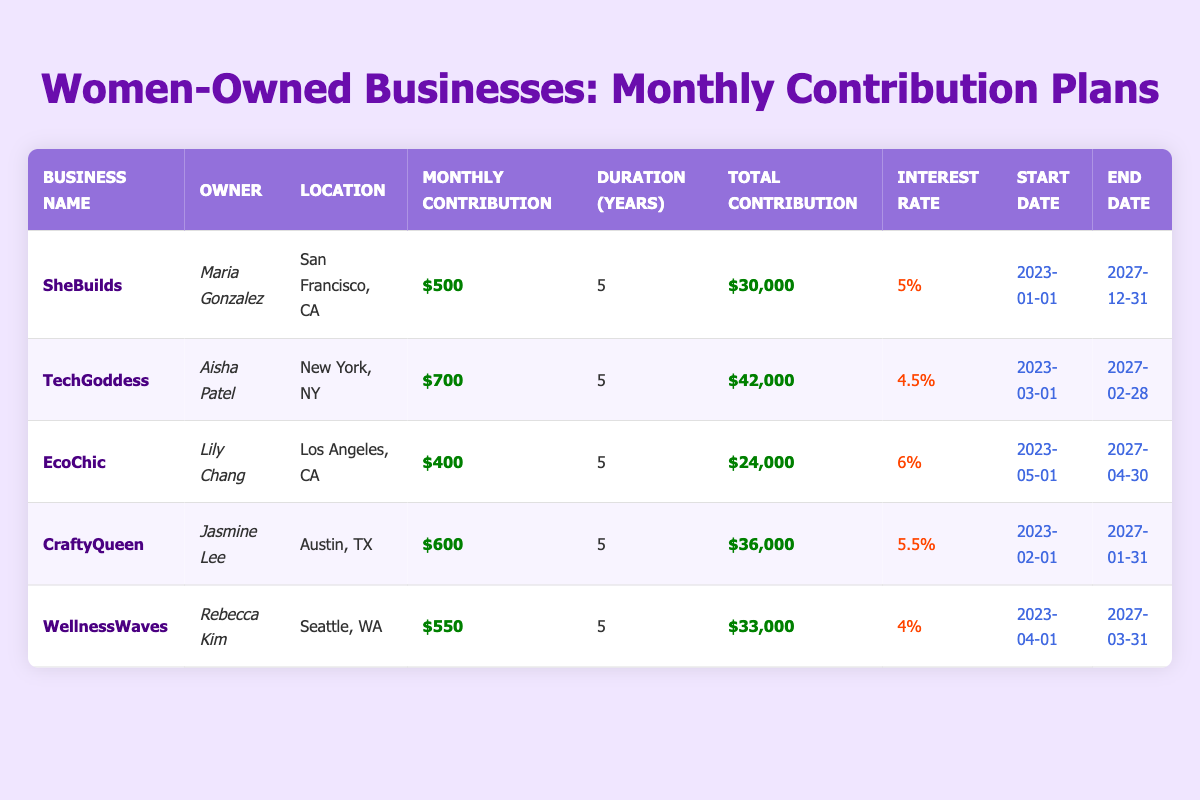What is the monthly contribution of EcoChic? EcoChic's row in the table shows a monthly contribution of $400.
Answer: $400 Which business has the highest total contribution? By comparing the total contributions listed, TechGoddess's total contribution is $42,000, which is the highest among the listed businesses.
Answer: TechGoddess How many businesses have an interest rate higher than 5%? The interest rates are listed as follows: SheBuilds (5%), TechGoddess (4.5%), EcoChic (6%), CraftyQueen (5.5%), and WellnessWaves (4%). Only EcoChic and CraftyQueen have rates higher than 5%, totaling to two businesses.
Answer: 2 What is the average monthly contribution across all businesses? To find the average, I will sum the monthly contributions: (500 + 700 + 400 + 600 + 550) = 2850. Then divide by the number of businesses (5): 2850 / 5 = 570.
Answer: $570 Does any business owner have a monthly contribution of $600? By checking the monthly contributions, I see that CraftyQueen's owner, Jasmine Lee, has a monthly contribution of $600, indicating that the statement is true.
Answer: Yes Which business is located in Seattle, WA? The table indicates that WellnessWaves is the business located in Seattle, WA as per the location column.
Answer: WellnessWaves What is the difference in total contributions between the highest and lowest? The highest total contribution is from TechGoddess ($42,000) and the lowest is from EcoChic ($24,000). The difference is $42,000 - $24,000 = $18,000.
Answer: $18,000 Is the duration of all businesses the same? The duration for all listed businesses is 5 years, confirming they all have the same duration.
Answer: Yes Which two businesses started their contribution plans in the same month? CraftyQueen and TechGoddess both started their plans in February 2023, which can be seen in the start date column.
Answer: CraftyQueen and TechGoddess 